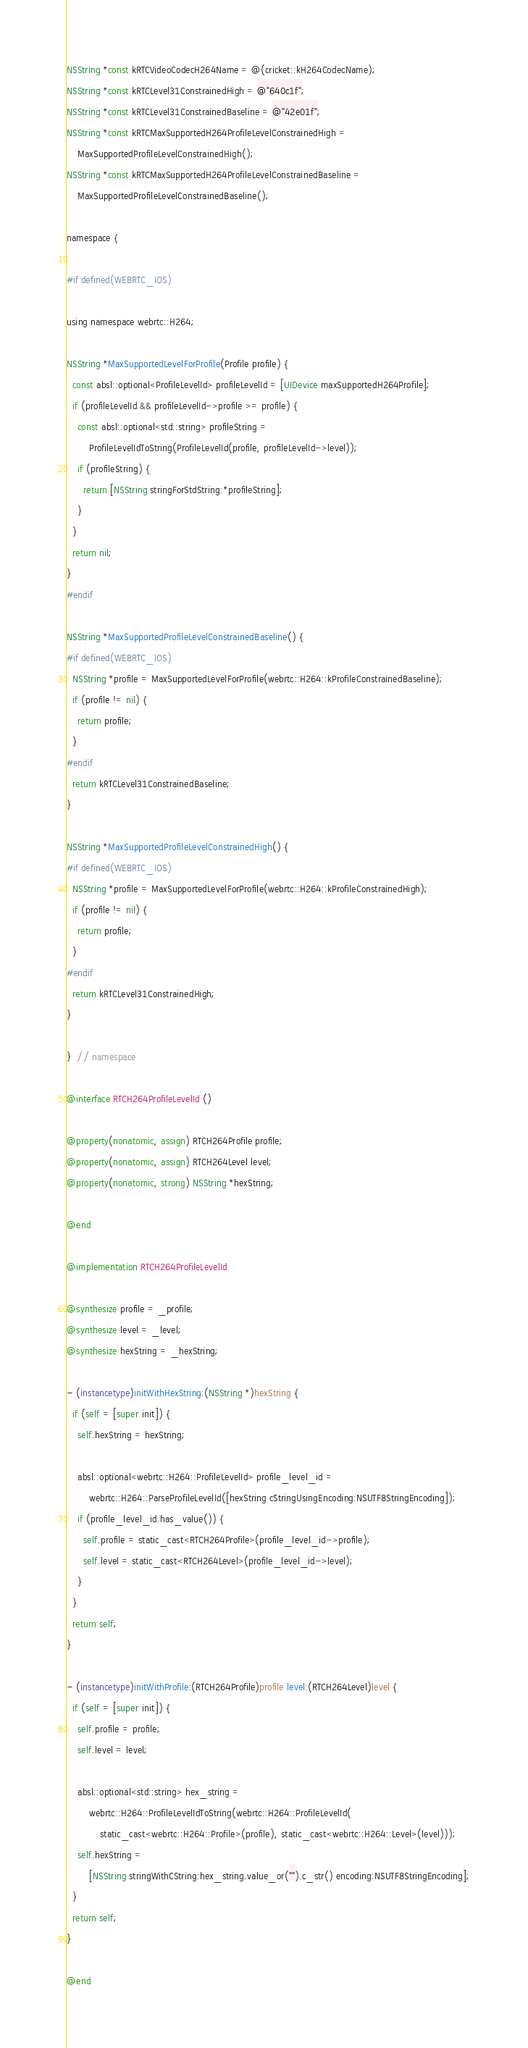Convert code to text. <code><loc_0><loc_0><loc_500><loc_500><_ObjectiveC_>
NSString *const kRTCVideoCodecH264Name = @(cricket::kH264CodecName);
NSString *const kRTCLevel31ConstrainedHigh = @"640c1f";
NSString *const kRTCLevel31ConstrainedBaseline = @"42e01f";
NSString *const kRTCMaxSupportedH264ProfileLevelConstrainedHigh =
    MaxSupportedProfileLevelConstrainedHigh();
NSString *const kRTCMaxSupportedH264ProfileLevelConstrainedBaseline =
    MaxSupportedProfileLevelConstrainedBaseline();

namespace {

#if defined(WEBRTC_IOS)

using namespace webrtc::H264;

NSString *MaxSupportedLevelForProfile(Profile profile) {
  const absl::optional<ProfileLevelId> profileLevelId = [UIDevice maxSupportedH264Profile];
  if (profileLevelId && profileLevelId->profile >= profile) {
    const absl::optional<std::string> profileString =
        ProfileLevelIdToString(ProfileLevelId(profile, profileLevelId->level));
    if (profileString) {
      return [NSString stringForStdString:*profileString];
    }
  }
  return nil;
}
#endif

NSString *MaxSupportedProfileLevelConstrainedBaseline() {
#if defined(WEBRTC_IOS)
  NSString *profile = MaxSupportedLevelForProfile(webrtc::H264::kProfileConstrainedBaseline);
  if (profile != nil) {
    return profile;
  }
#endif
  return kRTCLevel31ConstrainedBaseline;
}

NSString *MaxSupportedProfileLevelConstrainedHigh() {
#if defined(WEBRTC_IOS)
  NSString *profile = MaxSupportedLevelForProfile(webrtc::H264::kProfileConstrainedHigh);
  if (profile != nil) {
    return profile;
  }
#endif
  return kRTCLevel31ConstrainedHigh;
}

}  // namespace

@interface RTCH264ProfileLevelId ()

@property(nonatomic, assign) RTCH264Profile profile;
@property(nonatomic, assign) RTCH264Level level;
@property(nonatomic, strong) NSString *hexString;

@end

@implementation RTCH264ProfileLevelId

@synthesize profile = _profile;
@synthesize level = _level;
@synthesize hexString = _hexString;

- (instancetype)initWithHexString:(NSString *)hexString {
  if (self = [super init]) {
    self.hexString = hexString;

    absl::optional<webrtc::H264::ProfileLevelId> profile_level_id =
        webrtc::H264::ParseProfileLevelId([hexString cStringUsingEncoding:NSUTF8StringEncoding]);
    if (profile_level_id.has_value()) {
      self.profile = static_cast<RTCH264Profile>(profile_level_id->profile);
      self.level = static_cast<RTCH264Level>(profile_level_id->level);
    }
  }
  return self;
}

- (instancetype)initWithProfile:(RTCH264Profile)profile level:(RTCH264Level)level {
  if (self = [super init]) {
    self.profile = profile;
    self.level = level;

    absl::optional<std::string> hex_string =
        webrtc::H264::ProfileLevelIdToString(webrtc::H264::ProfileLevelId(
            static_cast<webrtc::H264::Profile>(profile), static_cast<webrtc::H264::Level>(level)));
    self.hexString =
        [NSString stringWithCString:hex_string.value_or("").c_str() encoding:NSUTF8StringEncoding];
  }
  return self;
}

@end
</code> 